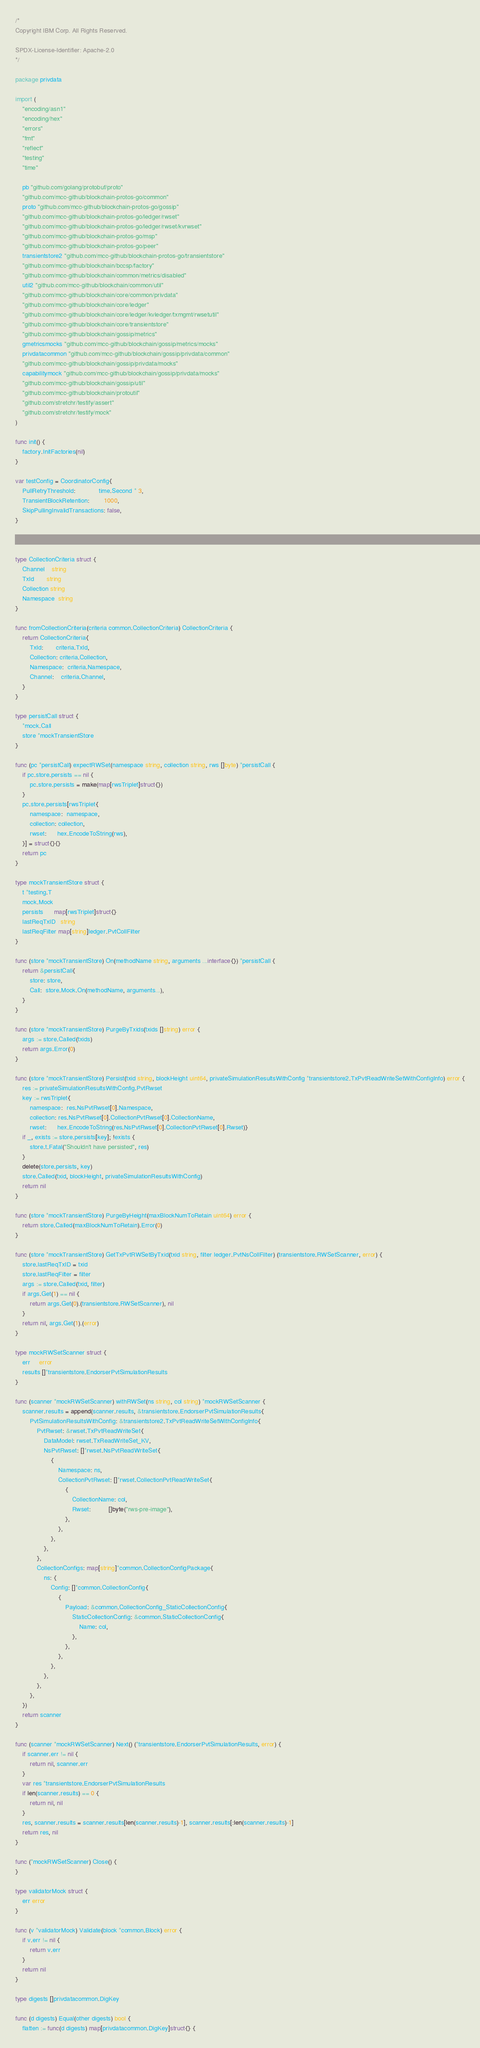<code> <loc_0><loc_0><loc_500><loc_500><_Go_>/*
Copyright IBM Corp. All Rights Reserved.

SPDX-License-Identifier: Apache-2.0
*/

package privdata

import (
	"encoding/asn1"
	"encoding/hex"
	"errors"
	"fmt"
	"reflect"
	"testing"
	"time"

	pb "github.com/golang/protobuf/proto"
	"github.com/mcc-github/blockchain-protos-go/common"
	proto "github.com/mcc-github/blockchain-protos-go/gossip"
	"github.com/mcc-github/blockchain-protos-go/ledger/rwset"
	"github.com/mcc-github/blockchain-protos-go/ledger/rwset/kvrwset"
	"github.com/mcc-github/blockchain-protos-go/msp"
	"github.com/mcc-github/blockchain-protos-go/peer"
	transientstore2 "github.com/mcc-github/blockchain-protos-go/transientstore"
	"github.com/mcc-github/blockchain/bccsp/factory"
	"github.com/mcc-github/blockchain/common/metrics/disabled"
	util2 "github.com/mcc-github/blockchain/common/util"
	"github.com/mcc-github/blockchain/core/common/privdata"
	"github.com/mcc-github/blockchain/core/ledger"
	"github.com/mcc-github/blockchain/core/ledger/kvledger/txmgmt/rwsetutil"
	"github.com/mcc-github/blockchain/core/transientstore"
	"github.com/mcc-github/blockchain/gossip/metrics"
	gmetricsmocks "github.com/mcc-github/blockchain/gossip/metrics/mocks"
	privdatacommon "github.com/mcc-github/blockchain/gossip/privdata/common"
	"github.com/mcc-github/blockchain/gossip/privdata/mocks"
	capabilitymock "github.com/mcc-github/blockchain/gossip/privdata/mocks"
	"github.com/mcc-github/blockchain/gossip/util"
	"github.com/mcc-github/blockchain/protoutil"
	"github.com/stretchr/testify/assert"
	"github.com/stretchr/testify/mock"
)

func init() {
	factory.InitFactories(nil)
}

var testConfig = CoordinatorConfig{
	PullRetryThreshold:             time.Second * 3,
	TransientBlockRetention:        1000,
	SkipPullingInvalidTransactions: false,
}



type CollectionCriteria struct {
	Channel    string
	TxId       string
	Collection string
	Namespace  string
}

func fromCollectionCriteria(criteria common.CollectionCriteria) CollectionCriteria {
	return CollectionCriteria{
		TxId:       criteria.TxId,
		Collection: criteria.Collection,
		Namespace:  criteria.Namespace,
		Channel:    criteria.Channel,
	}
}

type persistCall struct {
	*mock.Call
	store *mockTransientStore
}

func (pc *persistCall) expectRWSet(namespace string, collection string, rws []byte) *persistCall {
	if pc.store.persists == nil {
		pc.store.persists = make(map[rwsTriplet]struct{})
	}
	pc.store.persists[rwsTriplet{
		namespace:  namespace,
		collection: collection,
		rwset:      hex.EncodeToString(rws),
	}] = struct{}{}
	return pc
}

type mockTransientStore struct {
	t *testing.T
	mock.Mock
	persists      map[rwsTriplet]struct{}
	lastReqTxID   string
	lastReqFilter map[string]ledger.PvtCollFilter
}

func (store *mockTransientStore) On(methodName string, arguments ...interface{}) *persistCall {
	return &persistCall{
		store: store,
		Call:  store.Mock.On(methodName, arguments...),
	}
}

func (store *mockTransientStore) PurgeByTxids(txids []string) error {
	args := store.Called(txids)
	return args.Error(0)
}

func (store *mockTransientStore) Persist(txid string, blockHeight uint64, privateSimulationResultsWithConfig *transientstore2.TxPvtReadWriteSetWithConfigInfo) error {
	res := privateSimulationResultsWithConfig.PvtRwset
	key := rwsTriplet{
		namespace:  res.NsPvtRwset[0].Namespace,
		collection: res.NsPvtRwset[0].CollectionPvtRwset[0].CollectionName,
		rwset:      hex.EncodeToString(res.NsPvtRwset[0].CollectionPvtRwset[0].Rwset)}
	if _, exists := store.persists[key]; !exists {
		store.t.Fatal("Shouldn't have persisted", res)
	}
	delete(store.persists, key)
	store.Called(txid, blockHeight, privateSimulationResultsWithConfig)
	return nil
}

func (store *mockTransientStore) PurgeByHeight(maxBlockNumToRetain uint64) error {
	return store.Called(maxBlockNumToRetain).Error(0)
}

func (store *mockTransientStore) GetTxPvtRWSetByTxid(txid string, filter ledger.PvtNsCollFilter) (transientstore.RWSetScanner, error) {
	store.lastReqTxID = txid
	store.lastReqFilter = filter
	args := store.Called(txid, filter)
	if args.Get(1) == nil {
		return args.Get(0).(transientstore.RWSetScanner), nil
	}
	return nil, args.Get(1).(error)
}

type mockRWSetScanner struct {
	err     error
	results []*transientstore.EndorserPvtSimulationResults
}

func (scanner *mockRWSetScanner) withRWSet(ns string, col string) *mockRWSetScanner {
	scanner.results = append(scanner.results, &transientstore.EndorserPvtSimulationResults{
		PvtSimulationResultsWithConfig: &transientstore2.TxPvtReadWriteSetWithConfigInfo{
			PvtRwset: &rwset.TxPvtReadWriteSet{
				DataModel: rwset.TxReadWriteSet_KV,
				NsPvtRwset: []*rwset.NsPvtReadWriteSet{
					{
						Namespace: ns,
						CollectionPvtRwset: []*rwset.CollectionPvtReadWriteSet{
							{
								CollectionName: col,
								Rwset:          []byte("rws-pre-image"),
							},
						},
					},
				},
			},
			CollectionConfigs: map[string]*common.CollectionConfigPackage{
				ns: {
					Config: []*common.CollectionConfig{
						{
							Payload: &common.CollectionConfig_StaticCollectionConfig{
								StaticCollectionConfig: &common.StaticCollectionConfig{
									Name: col,
								},
							},
						},
					},
				},
			},
		},
	})
	return scanner
}

func (scanner *mockRWSetScanner) Next() (*transientstore.EndorserPvtSimulationResults, error) {
	if scanner.err != nil {
		return nil, scanner.err
	}
	var res *transientstore.EndorserPvtSimulationResults
	if len(scanner.results) == 0 {
		return nil, nil
	}
	res, scanner.results = scanner.results[len(scanner.results)-1], scanner.results[:len(scanner.results)-1]
	return res, nil
}

func (*mockRWSetScanner) Close() {
}

type validatorMock struct {
	err error
}

func (v *validatorMock) Validate(block *common.Block) error {
	if v.err != nil {
		return v.err
	}
	return nil
}

type digests []privdatacommon.DigKey

func (d digests) Equal(other digests) bool {
	flatten := func(d digests) map[privdatacommon.DigKey]struct{} {</code> 